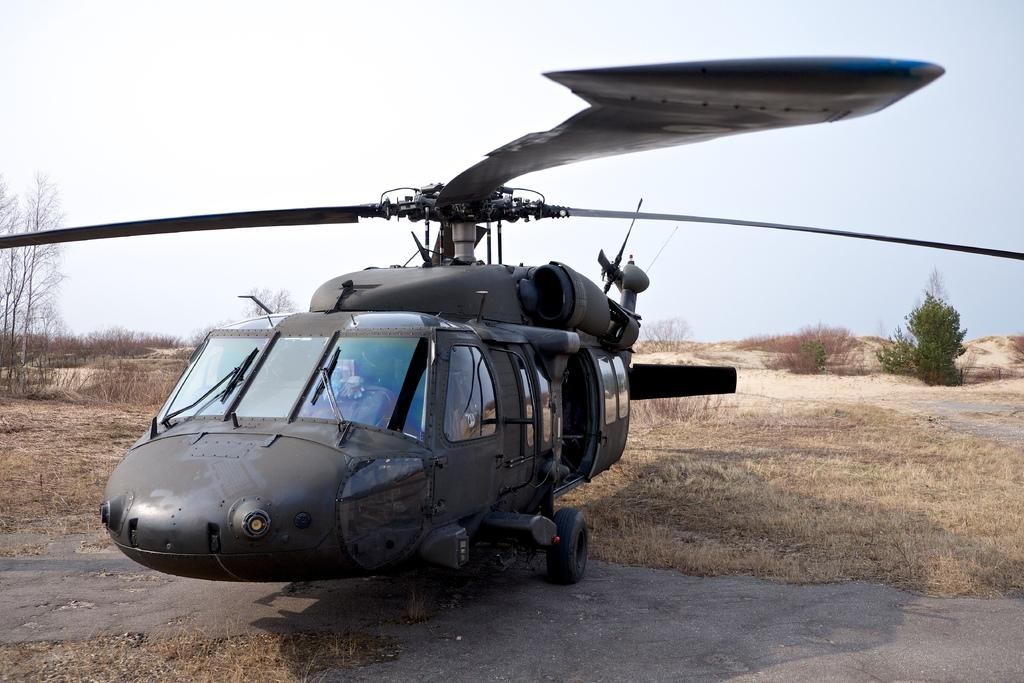What is the main subject of the image? The main subject of the image is a helicopter. Where is the helicopter located in the image? The helicopter is on the ground in the image. What can be seen in the background of the image? There are trees in the background of the image. What is visible at the top of the image? The sky is visible at the top of the image. What type of noise can be heard from the helicopter in the image? There is no sound present in the image, so it is not possible to determine the type of noise coming from the helicopter. 